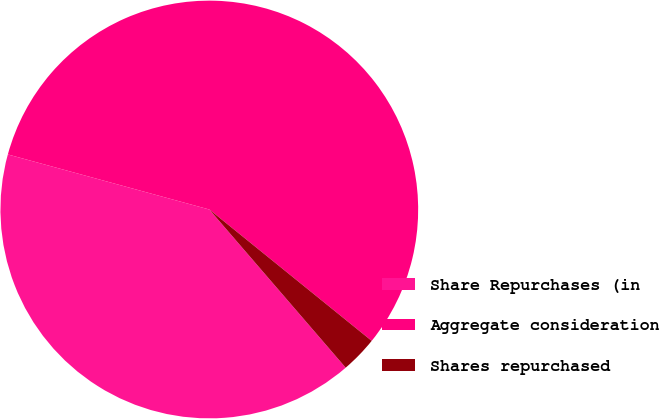Convert chart. <chart><loc_0><loc_0><loc_500><loc_500><pie_chart><fcel>Share Repurchases (in<fcel>Aggregate consideration<fcel>Shares repurchased<nl><fcel>40.57%<fcel>56.58%<fcel>2.85%<nl></chart> 